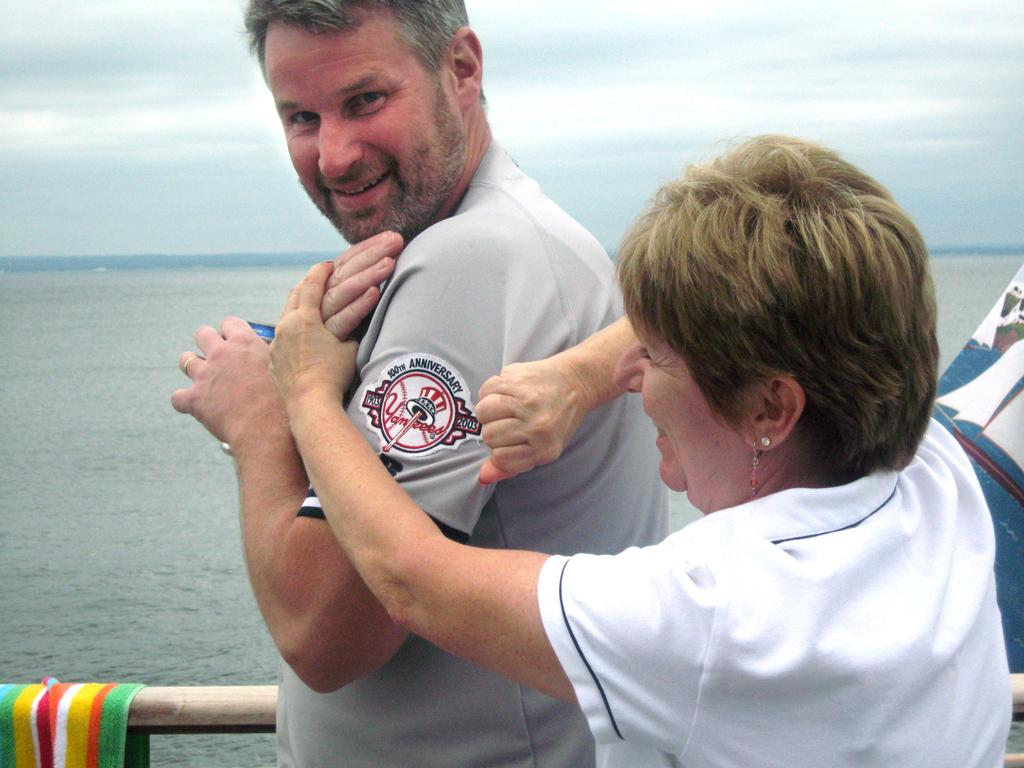<image>
Relay a brief, clear account of the picture shown. A woman holds a man's shirt to show the logo on his arm that says "Yankees" 